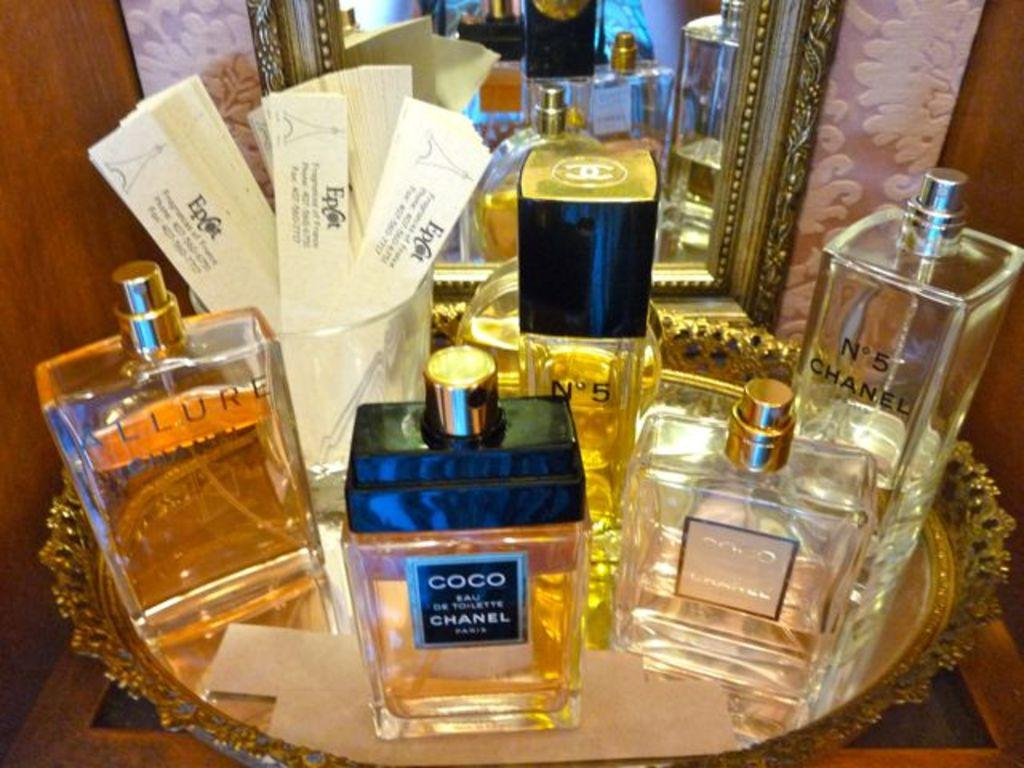<image>
Relay a brief, clear account of the picture shown. display of perfume including Coco Chanel and Allure 